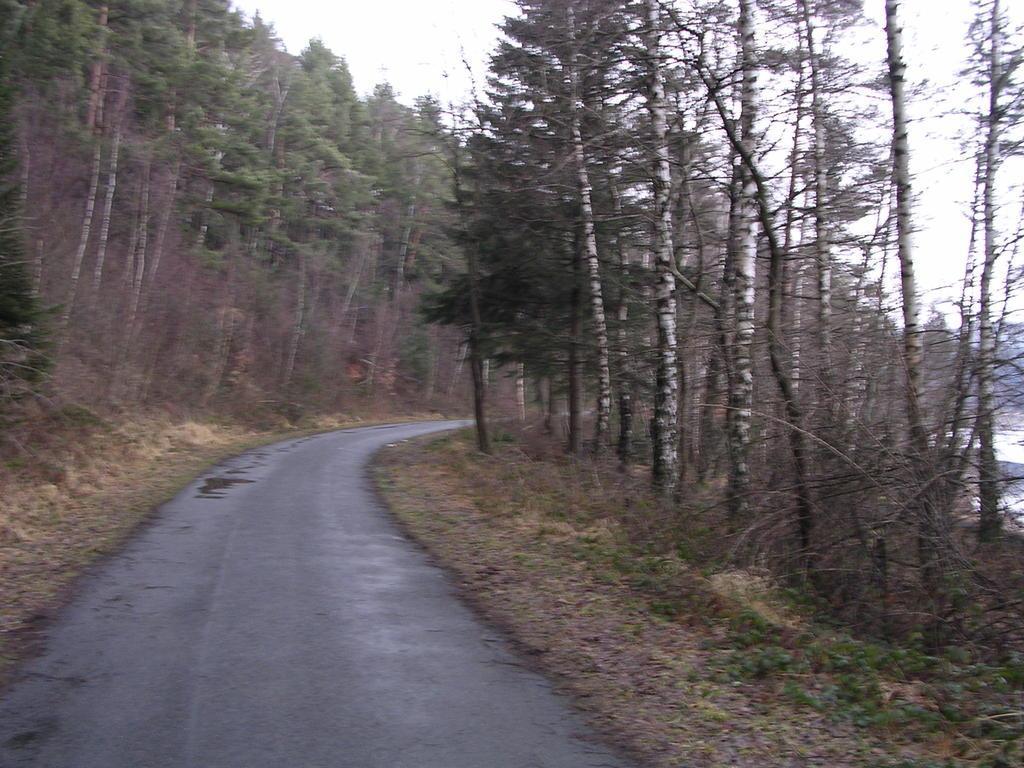In one or two sentences, can you explain what this image depicts? This image consists of grass, plants, trees, stones, some object and the sky. This image is taken may be on the road. 